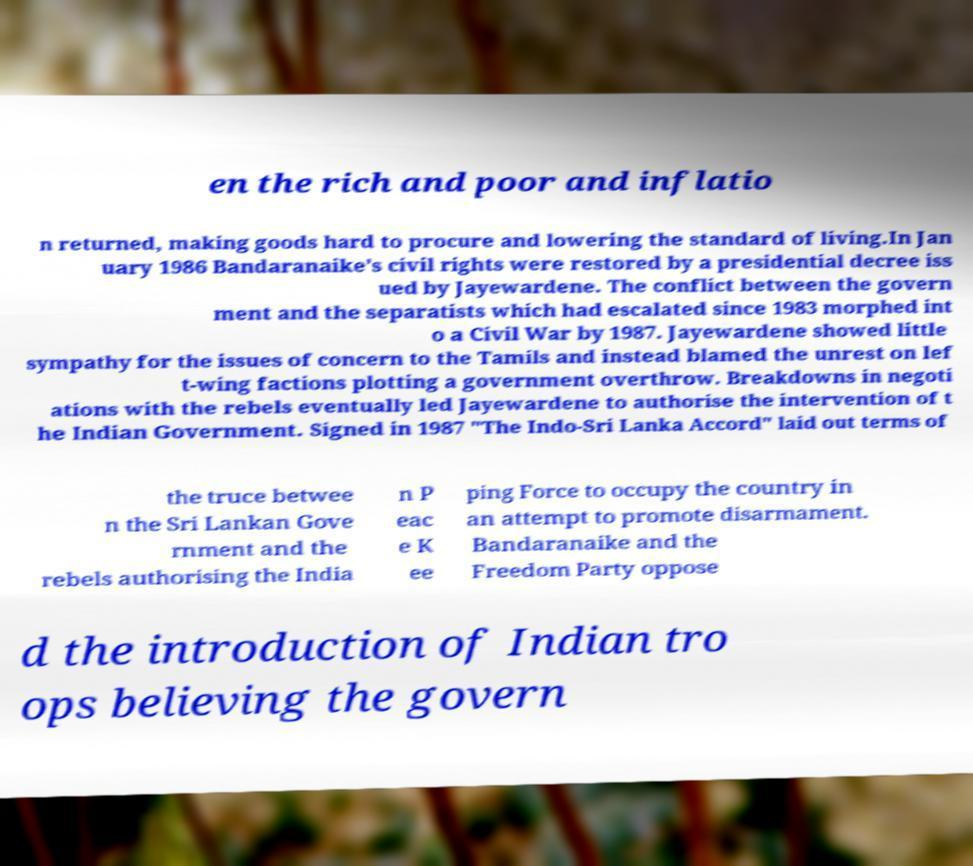Could you extract and type out the text from this image? en the rich and poor and inflatio n returned, making goods hard to procure and lowering the standard of living.In Jan uary 1986 Bandaranaike's civil rights were restored by a presidential decree iss ued by Jayewardene. The conflict between the govern ment and the separatists which had escalated since 1983 morphed int o a Civil War by 1987. Jayewardene showed little sympathy for the issues of concern to the Tamils and instead blamed the unrest on lef t-wing factions plotting a government overthrow. Breakdowns in negoti ations with the rebels eventually led Jayewardene to authorise the intervention of t he Indian Government. Signed in 1987 "The Indo-Sri Lanka Accord" laid out terms of the truce betwee n the Sri Lankan Gove rnment and the rebels authorising the India n P eac e K ee ping Force to occupy the country in an attempt to promote disarmament. Bandaranaike and the Freedom Party oppose d the introduction of Indian tro ops believing the govern 